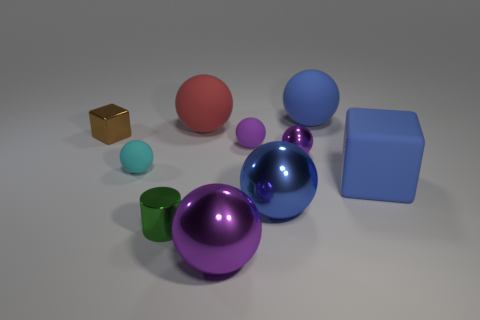Subtract all cyan cylinders. How many purple spheres are left? 3 Subtract 1 spheres. How many spheres are left? 6 Subtract all blue spheres. How many spheres are left? 5 Subtract all red spheres. How many spheres are left? 6 Subtract all blue spheres. Subtract all red cubes. How many spheres are left? 5 Subtract all blocks. How many objects are left? 8 Add 1 large blue objects. How many large blue objects exist? 4 Subtract 1 brown blocks. How many objects are left? 9 Subtract all brown metallic things. Subtract all large purple shiny balls. How many objects are left? 8 Add 7 cyan spheres. How many cyan spheres are left? 8 